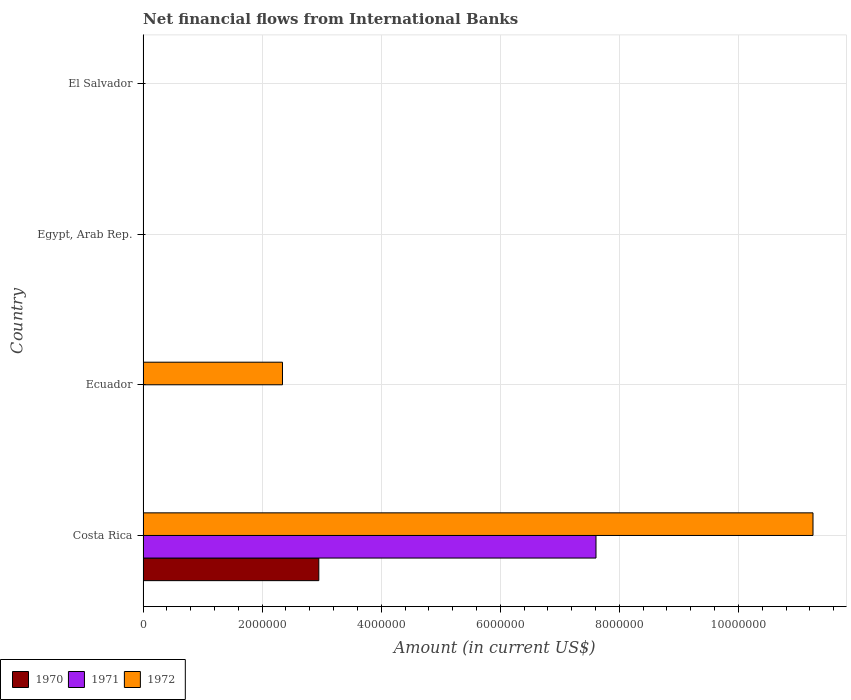Are the number of bars on each tick of the Y-axis equal?
Make the answer very short. No. How many bars are there on the 4th tick from the bottom?
Your response must be concise. 0. What is the label of the 1st group of bars from the top?
Provide a short and direct response. El Salvador. Across all countries, what is the maximum net financial aid flows in 1971?
Provide a succinct answer. 7.61e+06. In which country was the net financial aid flows in 1970 maximum?
Give a very brief answer. Costa Rica. What is the total net financial aid flows in 1971 in the graph?
Give a very brief answer. 7.61e+06. What is the difference between the net financial aid flows in 1972 in Costa Rica and that in Ecuador?
Your answer should be compact. 8.91e+06. What is the average net financial aid flows in 1970 per country?
Keep it short and to the point. 7.38e+05. What is the difference between the net financial aid flows in 1970 and net financial aid flows in 1971 in Costa Rica?
Your answer should be very brief. -4.66e+06. In how many countries, is the net financial aid flows in 1972 greater than 5200000 US$?
Your answer should be compact. 1. What is the difference between the highest and the lowest net financial aid flows in 1972?
Provide a short and direct response. 1.13e+07. How many bars are there?
Offer a very short reply. 4. Are all the bars in the graph horizontal?
Make the answer very short. Yes. How many countries are there in the graph?
Your answer should be very brief. 4. Are the values on the major ticks of X-axis written in scientific E-notation?
Your response must be concise. No. Does the graph contain any zero values?
Give a very brief answer. Yes. Where does the legend appear in the graph?
Provide a short and direct response. Bottom left. How many legend labels are there?
Your response must be concise. 3. What is the title of the graph?
Provide a succinct answer. Net financial flows from International Banks. What is the label or title of the X-axis?
Provide a succinct answer. Amount (in current US$). What is the Amount (in current US$) of 1970 in Costa Rica?
Ensure brevity in your answer.  2.95e+06. What is the Amount (in current US$) of 1971 in Costa Rica?
Provide a succinct answer. 7.61e+06. What is the Amount (in current US$) in 1972 in Costa Rica?
Offer a terse response. 1.13e+07. What is the Amount (in current US$) of 1971 in Ecuador?
Provide a short and direct response. 0. What is the Amount (in current US$) of 1972 in Ecuador?
Keep it short and to the point. 2.34e+06. What is the Amount (in current US$) of 1971 in Egypt, Arab Rep.?
Make the answer very short. 0. What is the Amount (in current US$) of 1972 in Egypt, Arab Rep.?
Make the answer very short. 0. What is the Amount (in current US$) in 1971 in El Salvador?
Give a very brief answer. 0. Across all countries, what is the maximum Amount (in current US$) of 1970?
Offer a terse response. 2.95e+06. Across all countries, what is the maximum Amount (in current US$) in 1971?
Ensure brevity in your answer.  7.61e+06. Across all countries, what is the maximum Amount (in current US$) in 1972?
Provide a succinct answer. 1.13e+07. Across all countries, what is the minimum Amount (in current US$) in 1970?
Your answer should be compact. 0. Across all countries, what is the minimum Amount (in current US$) in 1972?
Your response must be concise. 0. What is the total Amount (in current US$) of 1970 in the graph?
Your answer should be compact. 2.95e+06. What is the total Amount (in current US$) in 1971 in the graph?
Give a very brief answer. 7.61e+06. What is the total Amount (in current US$) of 1972 in the graph?
Your answer should be very brief. 1.36e+07. What is the difference between the Amount (in current US$) in 1972 in Costa Rica and that in Ecuador?
Your answer should be very brief. 8.91e+06. What is the difference between the Amount (in current US$) in 1970 in Costa Rica and the Amount (in current US$) in 1972 in Ecuador?
Offer a terse response. 6.10e+05. What is the difference between the Amount (in current US$) in 1971 in Costa Rica and the Amount (in current US$) in 1972 in Ecuador?
Your answer should be very brief. 5.27e+06. What is the average Amount (in current US$) of 1970 per country?
Give a very brief answer. 7.38e+05. What is the average Amount (in current US$) in 1971 per country?
Your answer should be compact. 1.90e+06. What is the average Amount (in current US$) of 1972 per country?
Make the answer very short. 3.40e+06. What is the difference between the Amount (in current US$) of 1970 and Amount (in current US$) of 1971 in Costa Rica?
Offer a terse response. -4.66e+06. What is the difference between the Amount (in current US$) of 1970 and Amount (in current US$) of 1972 in Costa Rica?
Offer a terse response. -8.30e+06. What is the difference between the Amount (in current US$) of 1971 and Amount (in current US$) of 1972 in Costa Rica?
Your answer should be very brief. -3.64e+06. What is the ratio of the Amount (in current US$) in 1972 in Costa Rica to that in Ecuador?
Provide a short and direct response. 4.8. What is the difference between the highest and the lowest Amount (in current US$) of 1970?
Keep it short and to the point. 2.95e+06. What is the difference between the highest and the lowest Amount (in current US$) of 1971?
Provide a succinct answer. 7.61e+06. What is the difference between the highest and the lowest Amount (in current US$) in 1972?
Provide a succinct answer. 1.13e+07. 